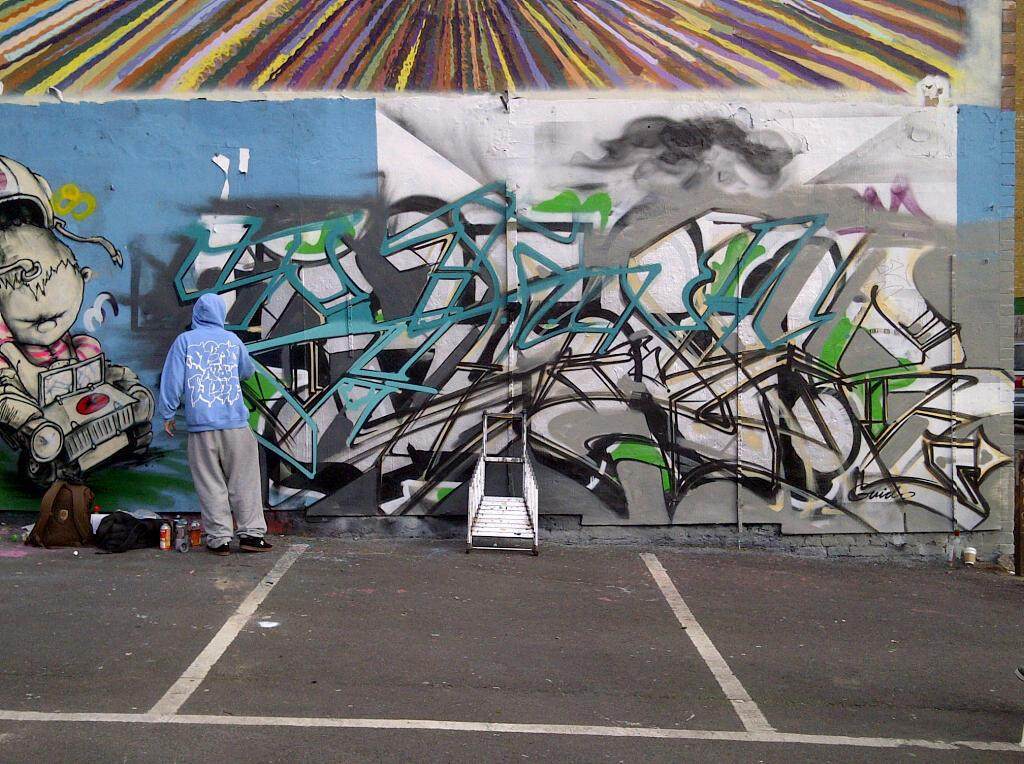What is on the wall in the image? There is graffiti on a wall in the image. What is in front of the wall? There is a person, bottles, bags, and an unspecified object in front of the wall. Can you describe the person in front of the wall? The facts provided do not give any details about the person's appearance or actions. How does the graffiti shake the wall in the image? The graffiti does not shake the wall in the image; it is a static image of graffiti on a wall. Are there any police officers visible in the image? The facts provided do not mention the presence of any police officers in the image. 